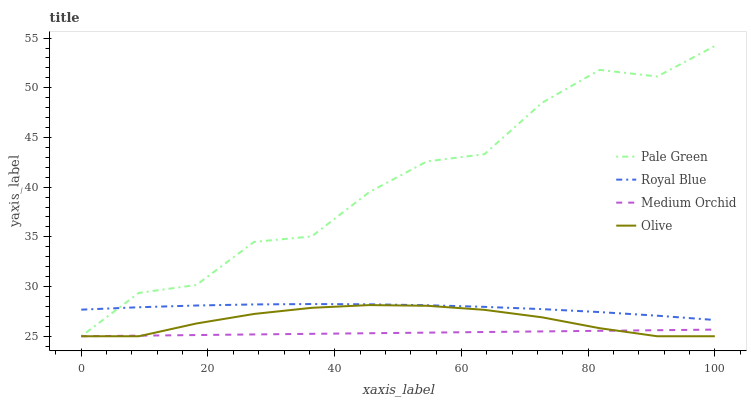Does Medium Orchid have the minimum area under the curve?
Answer yes or no. Yes. Does Pale Green have the maximum area under the curve?
Answer yes or no. Yes. Does Royal Blue have the minimum area under the curve?
Answer yes or no. No. Does Royal Blue have the maximum area under the curve?
Answer yes or no. No. Is Medium Orchid the smoothest?
Answer yes or no. Yes. Is Pale Green the roughest?
Answer yes or no. Yes. Is Royal Blue the smoothest?
Answer yes or no. No. Is Royal Blue the roughest?
Answer yes or no. No. Does Royal Blue have the lowest value?
Answer yes or no. No. Does Pale Green have the highest value?
Answer yes or no. Yes. Does Royal Blue have the highest value?
Answer yes or no. No. Is Medium Orchid less than Royal Blue?
Answer yes or no. Yes. Is Royal Blue greater than Medium Orchid?
Answer yes or no. Yes. Does Olive intersect Pale Green?
Answer yes or no. Yes. Is Olive less than Pale Green?
Answer yes or no. No. Is Olive greater than Pale Green?
Answer yes or no. No. Does Medium Orchid intersect Royal Blue?
Answer yes or no. No. 